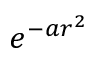<formula> <loc_0><loc_0><loc_500><loc_500>e ^ { - a r ^ { 2 } }</formula> 